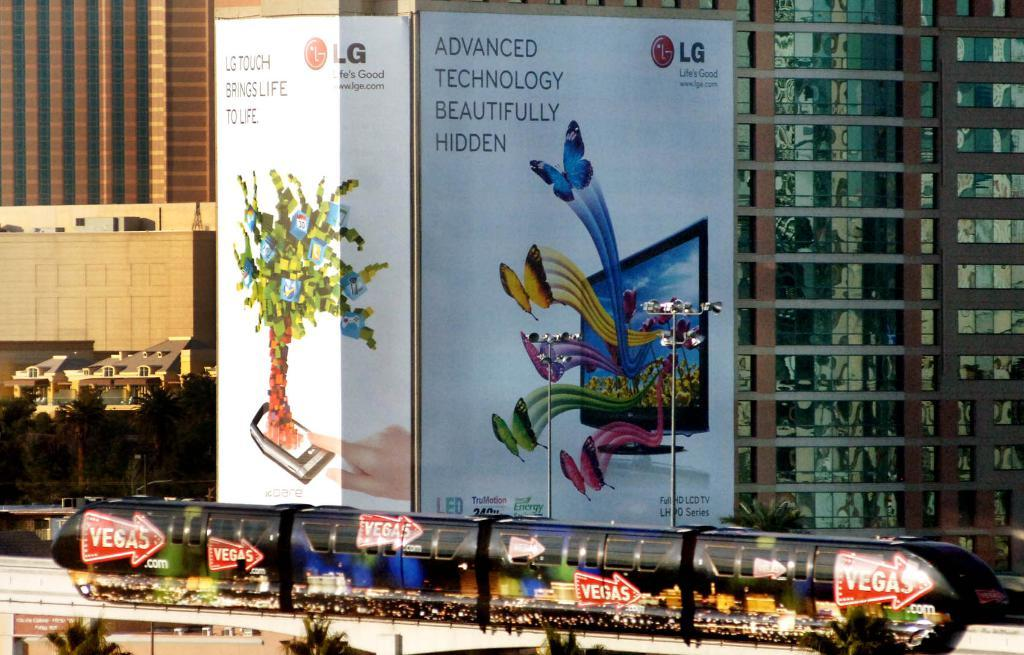Provide a one-sentence caption for the provided image. An ad for LG Touch on the side of a building. 